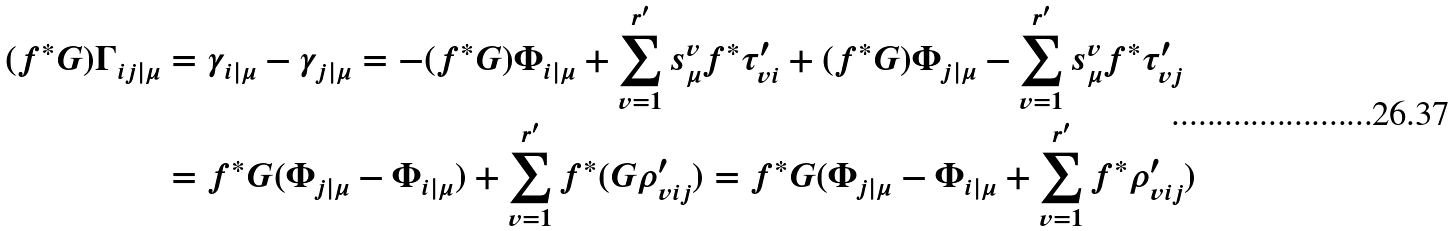<formula> <loc_0><loc_0><loc_500><loc_500>( f ^ { * } G ) \Gamma _ { i j | \mu } & = \gamma _ { i | \mu } - \gamma _ { j | \mu } = - ( f ^ { * } G ) \Phi _ { i | \mu } + \sum _ { v = 1 } ^ { r ^ { \prime } } s _ { \mu } ^ { v } f ^ { * } \tau _ { v i } ^ { \prime } + ( f ^ { * } G ) \Phi _ { j | \mu } - \sum _ { v = 1 } ^ { r ^ { \prime } } s _ { \mu } ^ { v } f ^ { * } \tau _ { v j } ^ { \prime } \\ & = f ^ { * } G ( \Phi _ { j | \mu } - \Phi _ { i | \mu } ) + \sum _ { v = 1 } ^ { r ^ { \prime } } f ^ { * } ( G \rho _ { v i j } ^ { \prime } ) = f ^ { * } G ( \Phi _ { j | \mu } - \Phi _ { i | \mu } + \sum _ { v = 1 } ^ { r ^ { \prime } } f ^ { * } \rho _ { v i j } ^ { \prime } )</formula> 